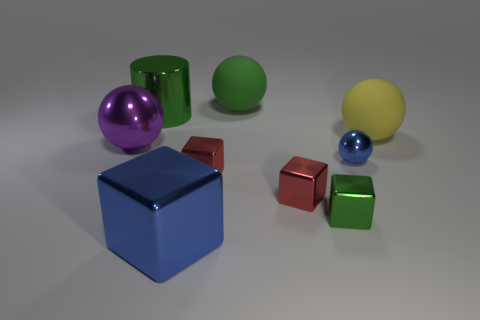Is there a green block that has the same material as the green cylinder?
Your response must be concise. Yes. There is a large metallic thing that is in front of the small red object that is to the right of the green object that is behind the large cylinder; what color is it?
Your response must be concise. Blue. Are the large sphere behind the big cylinder and the ball that is right of the tiny shiny ball made of the same material?
Offer a very short reply. Yes. There is a green thing that is in front of the tiny blue metallic object; what is its shape?
Give a very brief answer. Cube. How many objects are either blue balls or large green things that are to the left of the large blue block?
Offer a terse response. 2. Are the small ball and the green block made of the same material?
Ensure brevity in your answer.  Yes. Are there the same number of large rubber balls left of the tiny green block and blue shiny cubes that are behind the big shiny cylinder?
Ensure brevity in your answer.  No. How many metallic balls are in front of the big blue block?
Your answer should be compact. 0. What number of things are either green objects or cylinders?
Your answer should be compact. 3. How many blue cubes have the same size as the yellow ball?
Provide a succinct answer. 1. 